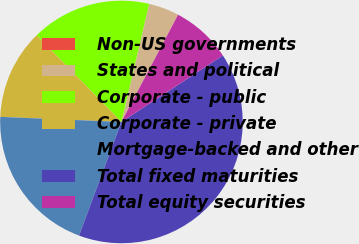<chart> <loc_0><loc_0><loc_500><loc_500><pie_chart><fcel>Non-US governments<fcel>States and political<fcel>Corporate - public<fcel>Corporate - private<fcel>Mortgage-backed and other<fcel>Total fixed maturities<fcel>Total equity securities<nl><fcel>0.04%<fcel>4.03%<fcel>15.99%<fcel>12.01%<fcel>19.98%<fcel>39.92%<fcel>8.02%<nl></chart> 